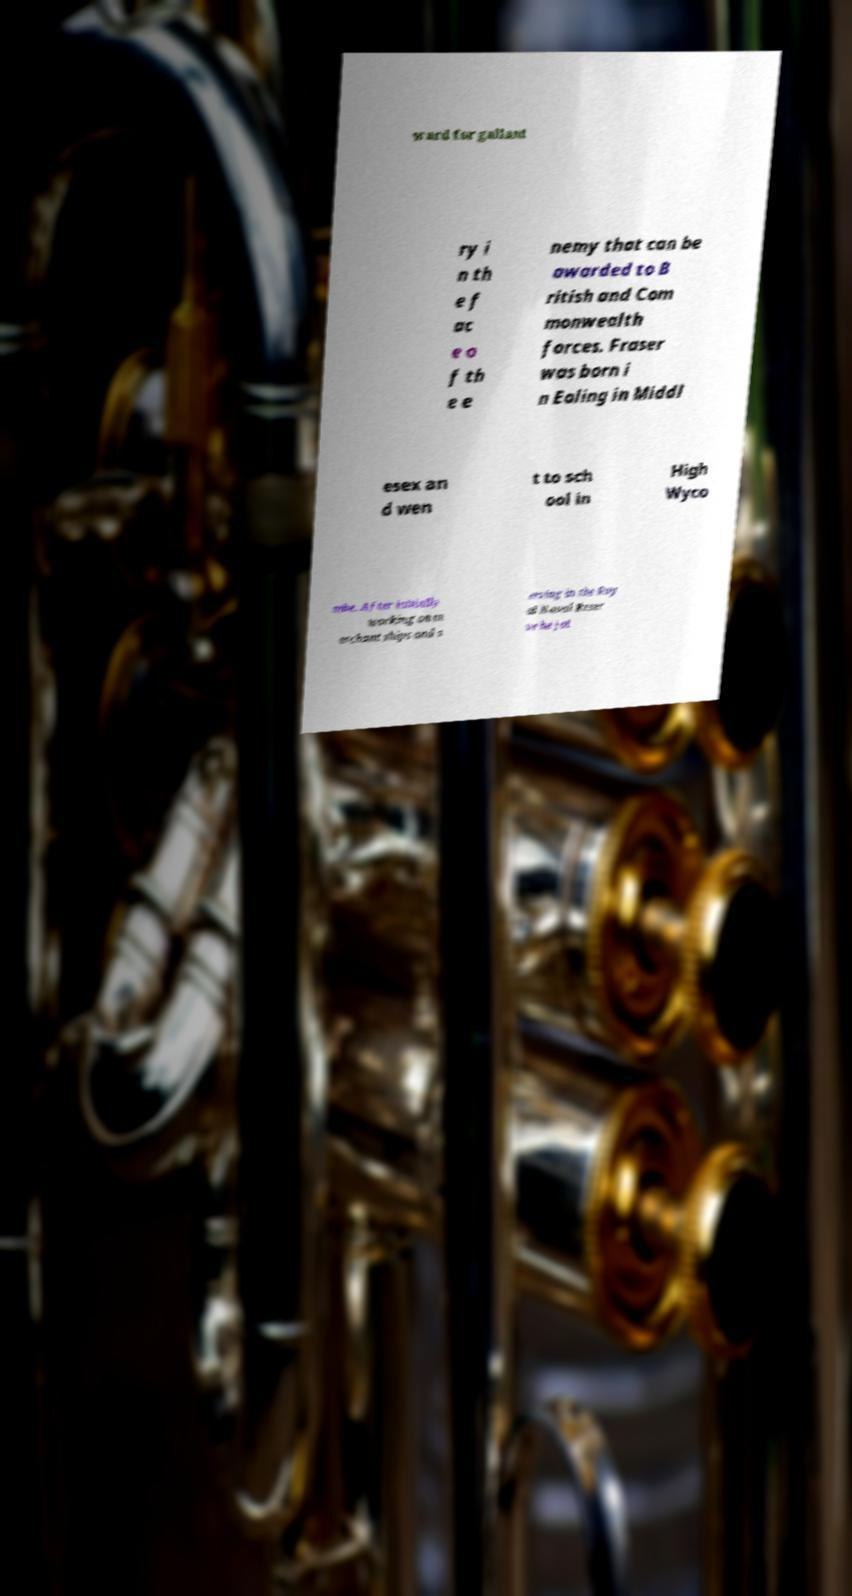Can you read and provide the text displayed in the image?This photo seems to have some interesting text. Can you extract and type it out for me? ward for gallant ry i n th e f ac e o f th e e nemy that can be awarded to B ritish and Com monwealth forces. Fraser was born i n Ealing in Middl esex an d wen t to sch ool in High Wyco mbe. After initially working on m erchant ships and s erving in the Roy al Naval Reser ve he joi 